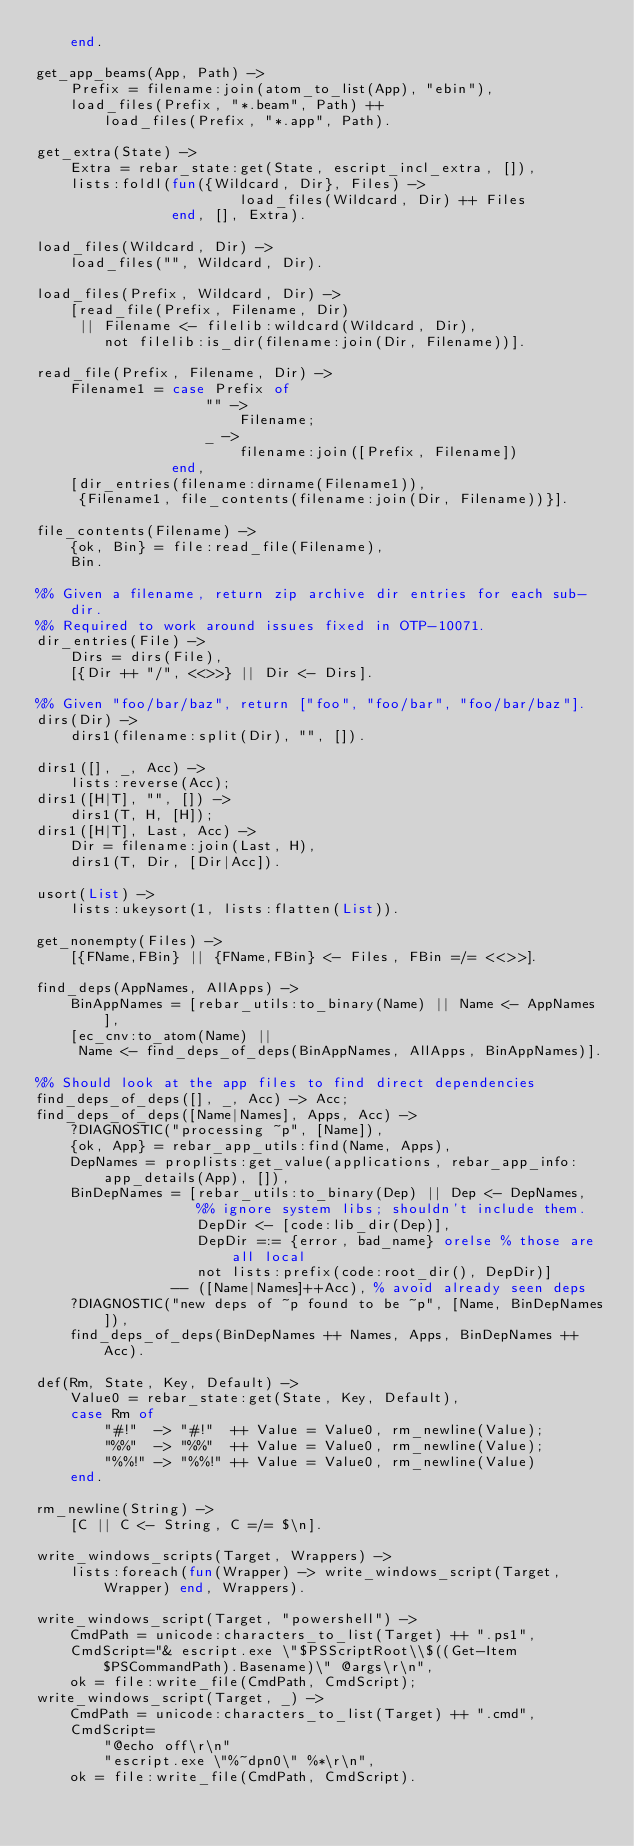<code> <loc_0><loc_0><loc_500><loc_500><_Erlang_>    end.

get_app_beams(App, Path) ->
    Prefix = filename:join(atom_to_list(App), "ebin"),
    load_files(Prefix, "*.beam", Path) ++
        load_files(Prefix, "*.app", Path).

get_extra(State) ->
    Extra = rebar_state:get(State, escript_incl_extra, []),
    lists:foldl(fun({Wildcard, Dir}, Files) ->
                        load_files(Wildcard, Dir) ++ Files
                end, [], Extra).

load_files(Wildcard, Dir) ->
    load_files("", Wildcard, Dir).

load_files(Prefix, Wildcard, Dir) ->
    [read_file(Prefix, Filename, Dir)
     || Filename <- filelib:wildcard(Wildcard, Dir),
        not filelib:is_dir(filename:join(Dir, Filename))].

read_file(Prefix, Filename, Dir) ->
    Filename1 = case Prefix of
                    "" ->
                        Filename;
                    _ ->
                        filename:join([Prefix, Filename])
                end,
    [dir_entries(filename:dirname(Filename1)),
     {Filename1, file_contents(filename:join(Dir, Filename))}].

file_contents(Filename) ->
    {ok, Bin} = file:read_file(Filename),
    Bin.

%% Given a filename, return zip archive dir entries for each sub-dir.
%% Required to work around issues fixed in OTP-10071.
dir_entries(File) ->
    Dirs = dirs(File),
    [{Dir ++ "/", <<>>} || Dir <- Dirs].

%% Given "foo/bar/baz", return ["foo", "foo/bar", "foo/bar/baz"].
dirs(Dir) ->
    dirs1(filename:split(Dir), "", []).

dirs1([], _, Acc) ->
    lists:reverse(Acc);
dirs1([H|T], "", []) ->
    dirs1(T, H, [H]);
dirs1([H|T], Last, Acc) ->
    Dir = filename:join(Last, H),
    dirs1(T, Dir, [Dir|Acc]).

usort(List) ->
    lists:ukeysort(1, lists:flatten(List)).

get_nonempty(Files) ->
    [{FName,FBin} || {FName,FBin} <- Files, FBin =/= <<>>].

find_deps(AppNames, AllApps) ->
    BinAppNames = [rebar_utils:to_binary(Name) || Name <- AppNames],
    [ec_cnv:to_atom(Name) ||
     Name <- find_deps_of_deps(BinAppNames, AllApps, BinAppNames)].

%% Should look at the app files to find direct dependencies
find_deps_of_deps([], _, Acc) -> Acc;
find_deps_of_deps([Name|Names], Apps, Acc) ->
    ?DIAGNOSTIC("processing ~p", [Name]),
    {ok, App} = rebar_app_utils:find(Name, Apps),
    DepNames = proplists:get_value(applications, rebar_app_info:app_details(App), []),
    BinDepNames = [rebar_utils:to_binary(Dep) || Dep <- DepNames,
                   %% ignore system libs; shouldn't include them.
                   DepDir <- [code:lib_dir(Dep)],
                   DepDir =:= {error, bad_name} orelse % those are all local
                   not lists:prefix(code:root_dir(), DepDir)]
                -- ([Name|Names]++Acc), % avoid already seen deps
    ?DIAGNOSTIC("new deps of ~p found to be ~p", [Name, BinDepNames]),
    find_deps_of_deps(BinDepNames ++ Names, Apps, BinDepNames ++ Acc).

def(Rm, State, Key, Default) ->
    Value0 = rebar_state:get(State, Key, Default),
    case Rm of
        "#!"  -> "#!"  ++ Value = Value0, rm_newline(Value);
        "%%"  -> "%%"  ++ Value = Value0, rm_newline(Value);
        "%%!" -> "%%!" ++ Value = Value0, rm_newline(Value)
    end.

rm_newline(String) ->
    [C || C <- String, C =/= $\n].

write_windows_scripts(Target, Wrappers) ->
    lists:foreach(fun(Wrapper) -> write_windows_script(Target, Wrapper) end, Wrappers).

write_windows_script(Target, "powershell") ->
    CmdPath = unicode:characters_to_list(Target) ++ ".ps1",
    CmdScript="& escript.exe \"$PSScriptRoot\\$((Get-Item $PSCommandPath).Basename)\" @args\r\n",
    ok = file:write_file(CmdPath, CmdScript);
write_windows_script(Target, _) ->
    CmdPath = unicode:characters_to_list(Target) ++ ".cmd",
    CmdScript=
        "@echo off\r\n"
        "escript.exe \"%~dpn0\" %*\r\n",
    ok = file:write_file(CmdPath, CmdScript).

</code> 